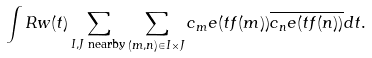<formula> <loc_0><loc_0><loc_500><loc_500>\int R w ( t ) \sum _ { I , J \text { nearby} } \sum _ { ( m , n ) \in I \times J } c _ { m } e ( t f ( m ) ) \overline { c _ { n } e ( t f ( n ) ) } d t .</formula> 